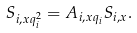Convert formula to latex. <formula><loc_0><loc_0><loc_500><loc_500>S _ { i , x q _ { i } ^ { 2 } } = A _ { i , x q _ { i } } S _ { i , x } .</formula> 